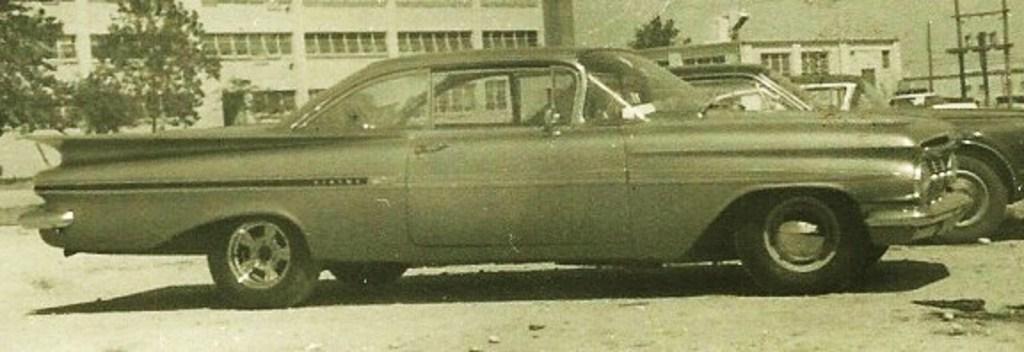Describe this image in one or two sentences. In this image in front there are cars parked on the road. In the background there are trees, buildings, transformer and sky. 